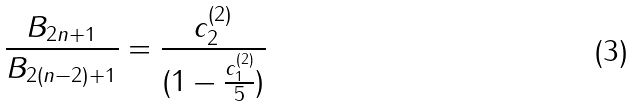Convert formula to latex. <formula><loc_0><loc_0><loc_500><loc_500>\frac { B _ { 2 n + 1 } } { B _ { 2 ( n - 2 ) + 1 } } = \frac { c _ { 2 } ^ { ( 2 ) } } { ( 1 - \frac { c _ { 1 } ^ { ( 2 ) } } { 5 } ) }</formula> 